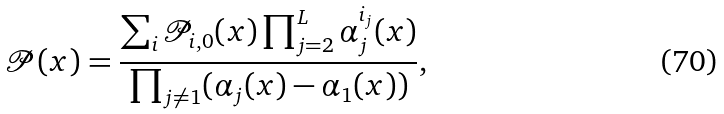Convert formula to latex. <formula><loc_0><loc_0><loc_500><loc_500>\mathcal { P } ( x ) = \frac { \sum _ { i } \mathcal { P } _ { i , 0 } ( x ) \prod _ { j = 2 } ^ { L } \alpha ^ { i _ { j } } _ { j } ( x ) } { \prod _ { j \neq 1 } ( \alpha _ { j } ( x ) - \alpha _ { 1 } ( x ) ) } ,</formula> 